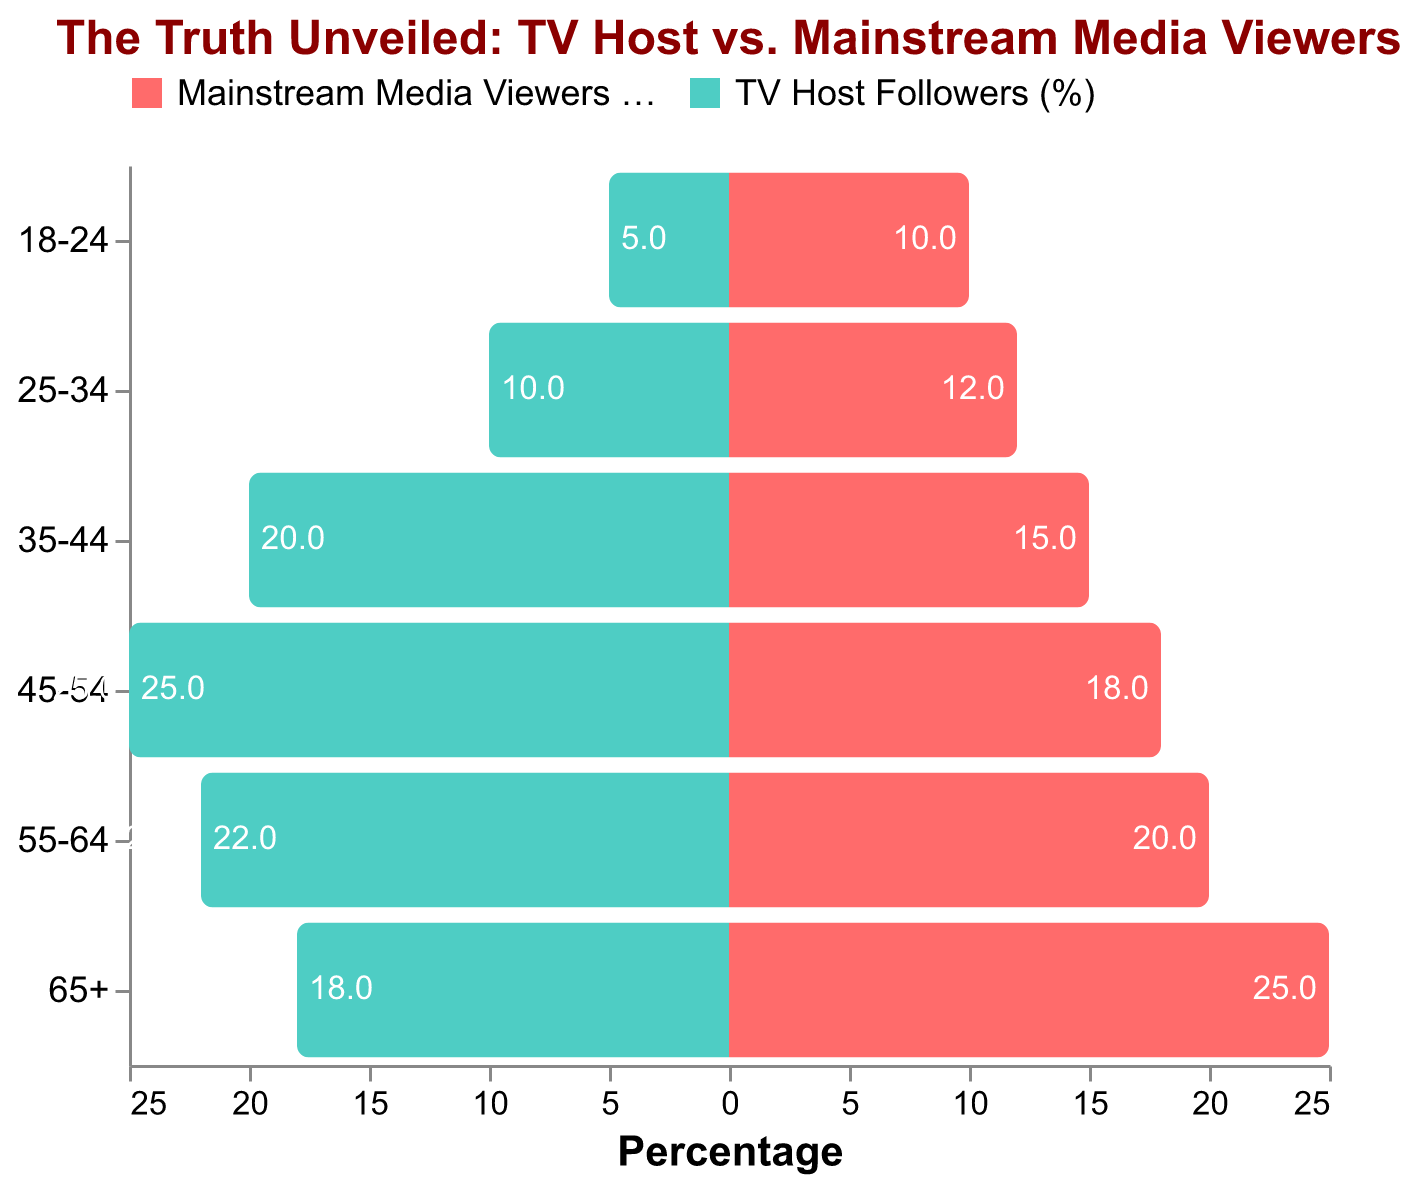What's the title of the figure? The title is typically found at the top of the figure and summarizes the main subject.
Answer: The Truth Unveiled: TV Host vs. Mainstream Media Viewers Which age group has the highest percentage of TV Host Followers? By looking at the bars representing the TV Host Followers (%), the 45-54 age group has the longest bar.
Answer: 45-54 How many percentage points higher is the 65+ group for Mainstream Media Viewers compared to TV Host Followers? For 65+ group, the percentage for Mainstream Media Viewers is 25% and for TV Host Followers is 18%. The difference is 25 - 18 = 7 percentage points.
Answer: 7 In which age group do the TV Host Followers (%) and Mainstream Media Viewers (%) have the closest percentage? Looking at all groups, the 55-64 group has TV Host Followers (%) at 22% and Mainstream Media Viewers (%) at 20%, creating a 2 percentage points difference which is the smallest.
Answer: 55-64 What is the combined percentage of TV Host Followers and Mainstream Media Viewers in the 25-34 age group? The percentage for TV Host Followers is 10% and for Mainstream Media Viewers is 12%. Summing them gives 10 + 12 = 22%.
Answer: 22 Which age group has the largest difference in percentage between TV Host Followers and Mainstream Media Viewers? By visually comparing the lengths of the bars, the 18-24 group has the largest difference, with 10% (Mainstream Media Viewers) - 5% (TV Host Followers) = 5 percentage points.
Answer: 18-24 How does the percentage of TV Host Followers in the 35-44 age group compare with the Mainstream Media Viewers in the same group? The percentage for TV Host Followers is higher at 20% compared to 15% for Mainstream Media Viewers.
Answer: TV Host Followers > Mainstream Media Viewers What age group shows the highest percentage of Mainstream Media Viewers? By looking at the bars representing Mainstream Media Viewers (%), the 65+ age group shows the highest percentage.
Answer: 65+ Is there any age group where TV Host Followers (%) exceed Mainstream Media Viewers (%)? If so, in which age group(s)? By comparing the bars for both groups, TV Host Followers (%) exceed Mainstream Media Viewers (%) in the 45-54 and 35-44 age groups.
Answer: 45-54 and 35-44 